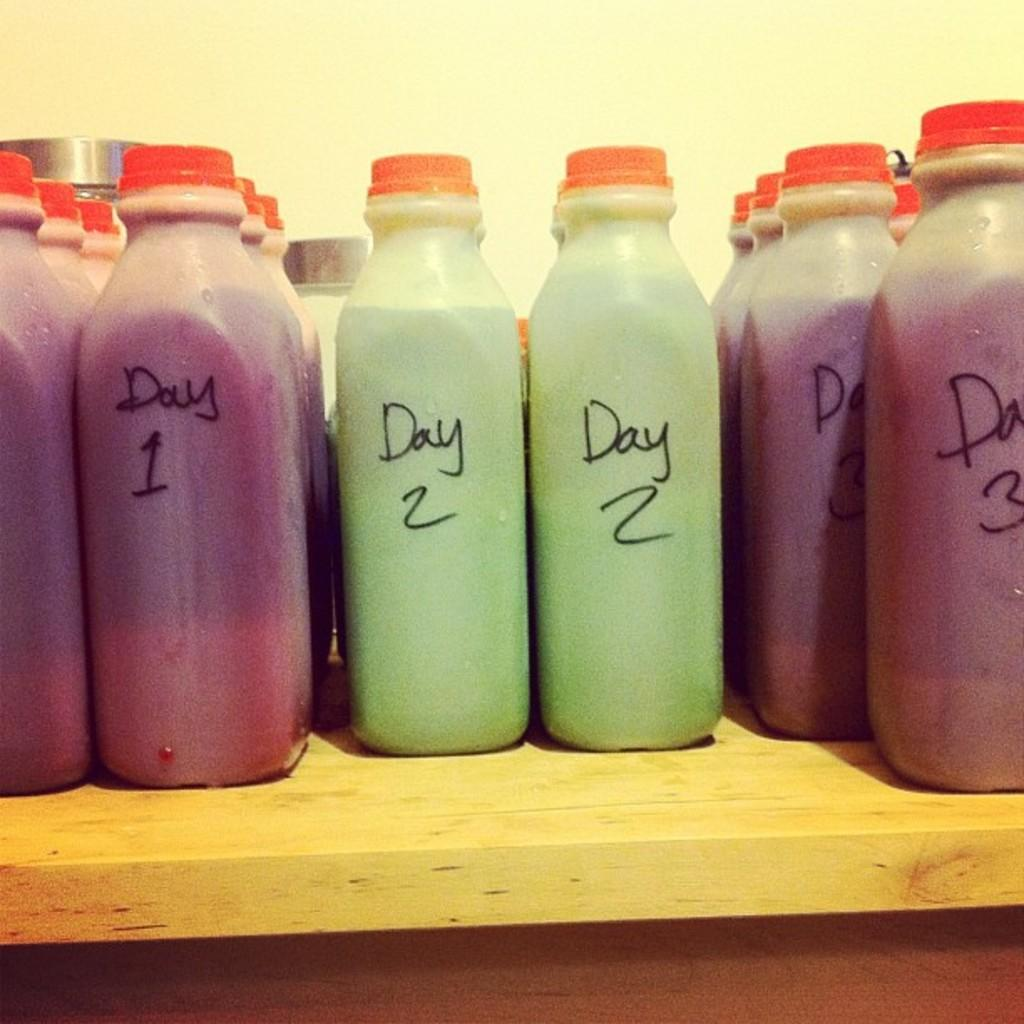<image>
Describe the image concisely. bottles of juice read Day 1, Day 2 and Day 3 